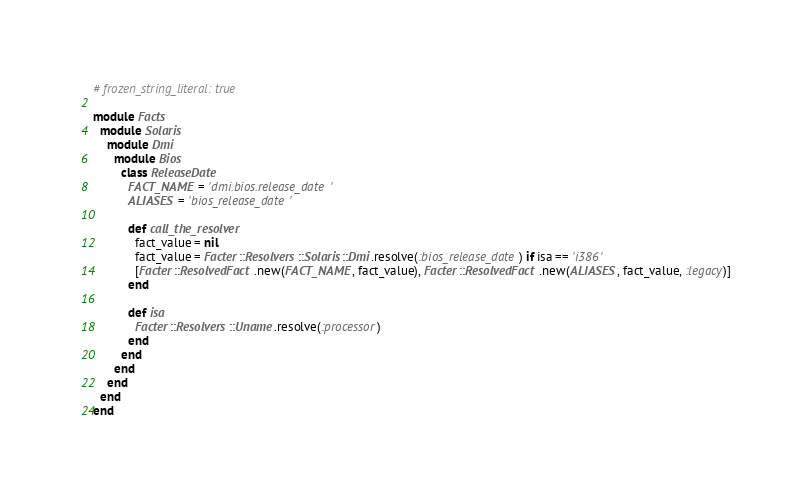Convert code to text. <code><loc_0><loc_0><loc_500><loc_500><_Ruby_># frozen_string_literal: true

module Facts
  module Solaris
    module Dmi
      module Bios
        class ReleaseDate
          FACT_NAME = 'dmi.bios.release_date'
          ALIASES = 'bios_release_date'

          def call_the_resolver
            fact_value = nil
            fact_value = Facter::Resolvers::Solaris::Dmi.resolve(:bios_release_date) if isa == 'i386'
            [Facter::ResolvedFact.new(FACT_NAME, fact_value), Facter::ResolvedFact.new(ALIASES, fact_value, :legacy)]
          end

          def isa
            Facter::Resolvers::Uname.resolve(:processor)
          end
        end
      end
    end
  end
end
</code> 